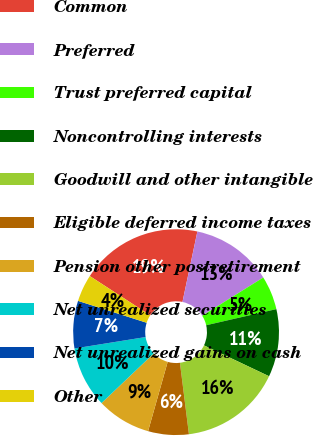Convert chart. <chart><loc_0><loc_0><loc_500><loc_500><pie_chart><fcel>Common<fcel>Preferred<fcel>Trust preferred capital<fcel>Noncontrolling interests<fcel>Goodwill and other intangible<fcel>Eligible deferred income taxes<fcel>Pension other postretirement<fcel>Net unrealized securities<fcel>Net unrealized gains on cash<fcel>Other<nl><fcel>19.15%<fcel>12.77%<fcel>5.32%<fcel>10.64%<fcel>15.96%<fcel>6.38%<fcel>8.51%<fcel>9.57%<fcel>7.45%<fcel>4.26%<nl></chart> 